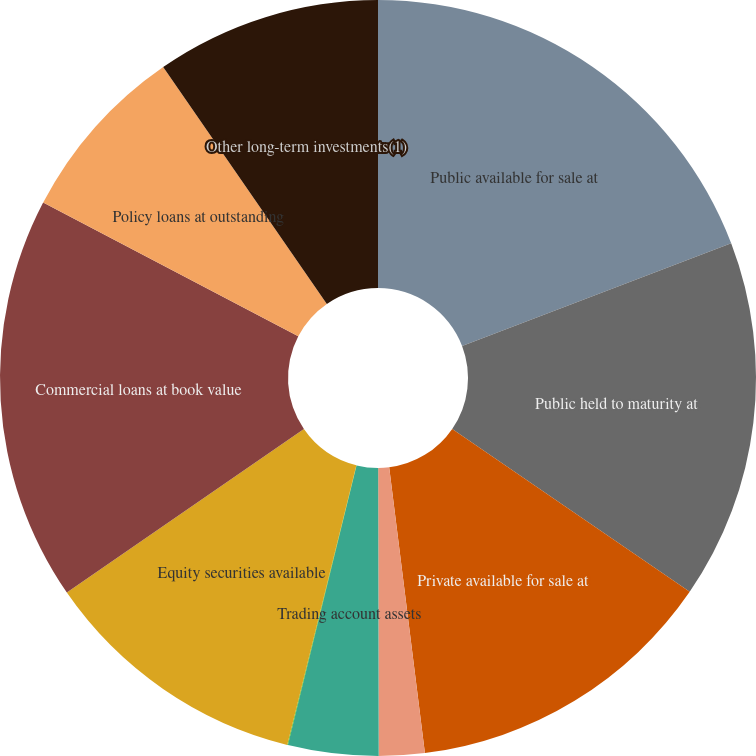<chart> <loc_0><loc_0><loc_500><loc_500><pie_chart><fcel>Public available for sale at<fcel>Public held to maturity at<fcel>Private available for sale at<fcel>Private held to maturity at<fcel>Trading account assets<fcel>Other trading account assets<fcel>Equity securities available<fcel>Commercial loans at book value<fcel>Policy loans at outstanding<fcel>Other long-term investments(1)<nl><fcel>19.2%<fcel>15.37%<fcel>13.45%<fcel>1.95%<fcel>3.86%<fcel>0.03%<fcel>11.53%<fcel>17.29%<fcel>7.7%<fcel>9.62%<nl></chart> 